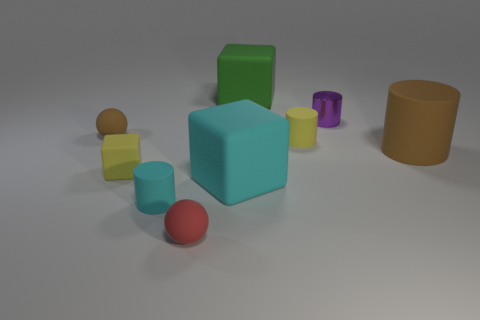Are there any other things that have the same material as the purple thing?
Keep it short and to the point. No. The green thing that is the same material as the tiny yellow cylinder is what size?
Offer a very short reply. Large. What is the size of the green cube?
Keep it short and to the point. Large. The tiny object that is the same color as the big cylinder is what shape?
Provide a succinct answer. Sphere. There is a tiny sphere behind the small cyan rubber thing; does it have the same color as the large rubber object on the right side of the small purple cylinder?
Keep it short and to the point. Yes. There is a green rubber thing; how many red balls are to the right of it?
Your answer should be very brief. 0. Are there any big rubber objects of the same shape as the shiny object?
Your answer should be compact. Yes. What is the color of the other metallic cylinder that is the same size as the cyan cylinder?
Give a very brief answer. Purple. Is the number of tiny purple metal cylinders that are in front of the red thing less than the number of brown rubber things to the right of the metallic cylinder?
Give a very brief answer. Yes. There is a brown thing behind the yellow cylinder; does it have the same size as the green rubber thing?
Give a very brief answer. No. 